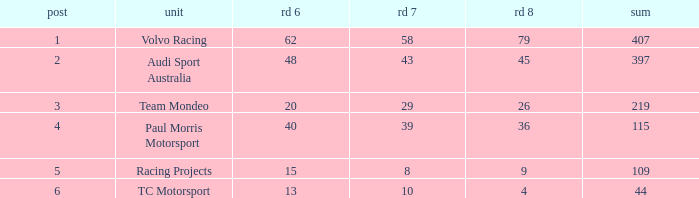What is the average value for Rd 8 in a position less than 2 for Audi Sport Australia? None. 